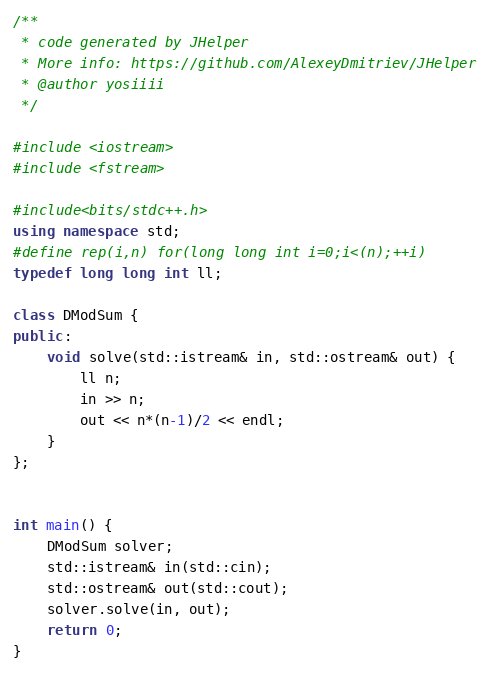Convert code to text. <code><loc_0><loc_0><loc_500><loc_500><_C++_>/**
 * code generated by JHelper
 * More info: https://github.com/AlexeyDmitriev/JHelper
 * @author yosiiii
 */

#include <iostream>
#include <fstream>

#include<bits/stdc++.h>
using namespace std;
#define rep(i,n) for(long long int i=0;i<(n);++i)
typedef long long int ll;

class DModSum {
public:
	void solve(std::istream& in, std::ostream& out) {
        ll n;
        in >> n;
        out << n*(n-1)/2 << endl;
	}
};


int main() {
	DModSum solver;
	std::istream& in(std::cin);
	std::ostream& out(std::cout);
	solver.solve(in, out);
	return 0;
}
</code> 